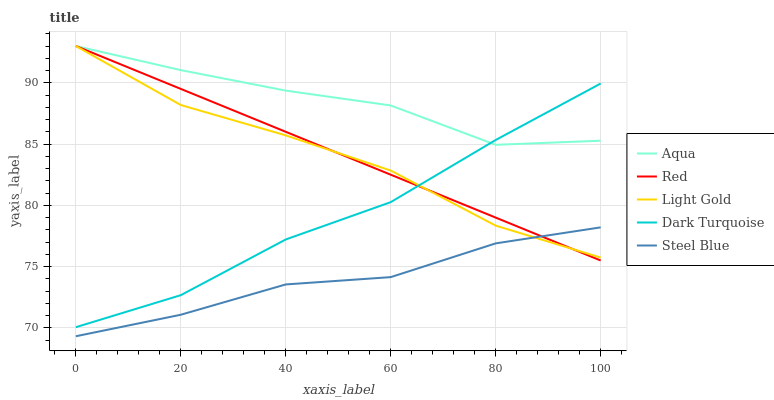Does Steel Blue have the minimum area under the curve?
Answer yes or no. Yes. Does Aqua have the maximum area under the curve?
Answer yes or no. Yes. Does Aqua have the minimum area under the curve?
Answer yes or no. No. Does Steel Blue have the maximum area under the curve?
Answer yes or no. No. Is Red the smoothest?
Answer yes or no. Yes. Is Aqua the roughest?
Answer yes or no. Yes. Is Steel Blue the smoothest?
Answer yes or no. No. Is Steel Blue the roughest?
Answer yes or no. No. Does Steel Blue have the lowest value?
Answer yes or no. Yes. Does Aqua have the lowest value?
Answer yes or no. No. Does Red have the highest value?
Answer yes or no. Yes. Does Steel Blue have the highest value?
Answer yes or no. No. Is Steel Blue less than Aqua?
Answer yes or no. Yes. Is Aqua greater than Steel Blue?
Answer yes or no. Yes. Does Steel Blue intersect Red?
Answer yes or no. Yes. Is Steel Blue less than Red?
Answer yes or no. No. Is Steel Blue greater than Red?
Answer yes or no. No. Does Steel Blue intersect Aqua?
Answer yes or no. No. 